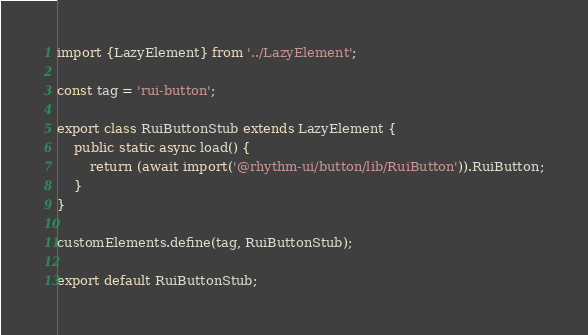Convert code to text. <code><loc_0><loc_0><loc_500><loc_500><_TypeScript_>import {LazyElement} from '../LazyElement';

const tag = 'rui-button';

export class RuiButtonStub extends LazyElement {
	public static async load() {
		return (await import('@rhythm-ui/button/lib/RuiButton')).RuiButton;
	}
}

customElements.define(tag, RuiButtonStub);

export default RuiButtonStub;
</code> 